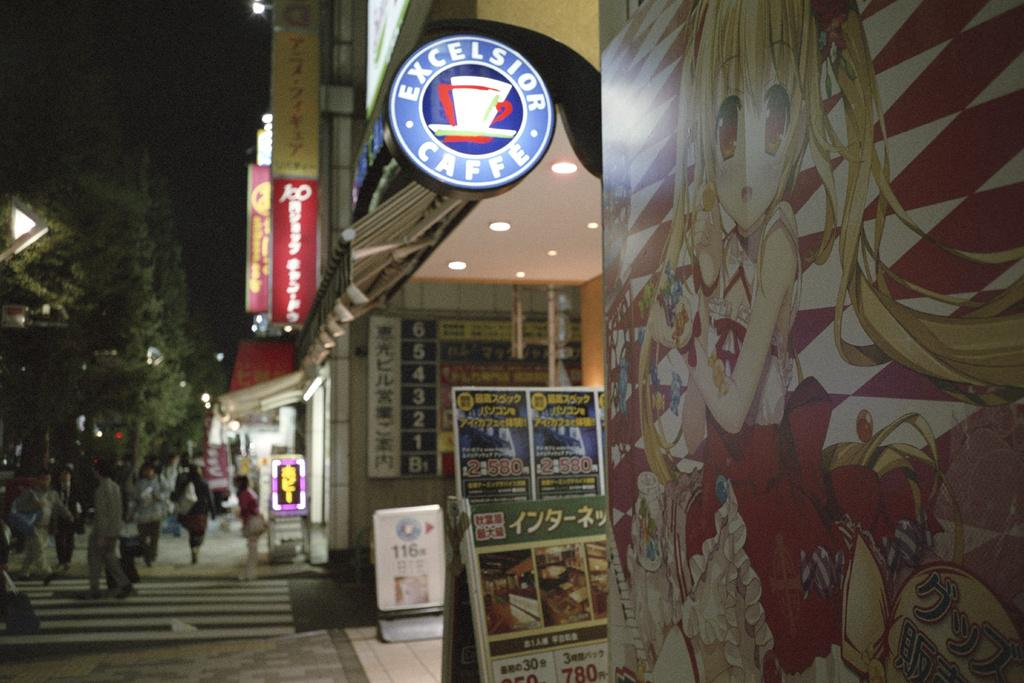<image>
Write a terse but informative summary of the picture. The exterior of Exclesiro Caffe is lit up on the sidewalk at night. 